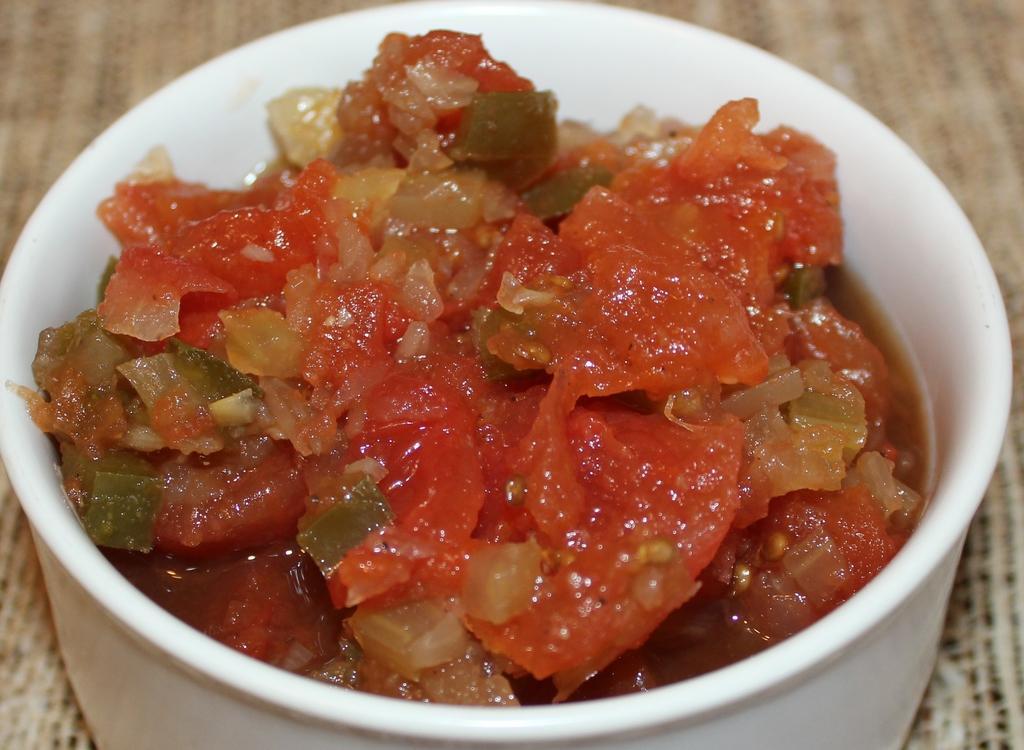Please provide a concise description of this image. In this image we can see a bowl containing food placed on the table. 